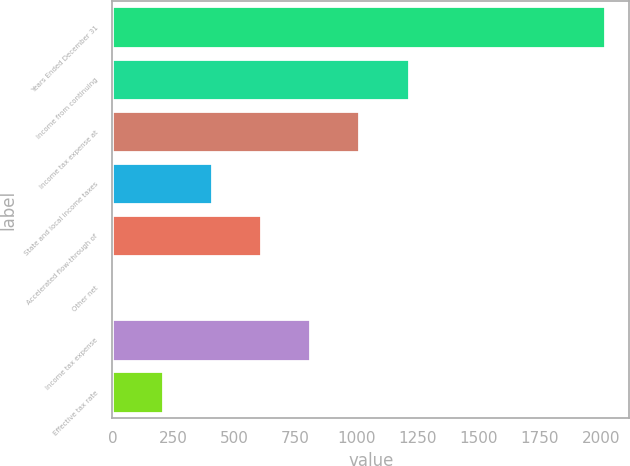Convert chart. <chart><loc_0><loc_0><loc_500><loc_500><bar_chart><fcel>Years Ended December 31<fcel>Income from continuing<fcel>Income tax expense at<fcel>State and local income taxes<fcel>Accelerated flow-through of<fcel>Other net<fcel>Income tax expense<fcel>Effective tax rate<nl><fcel>2016<fcel>1212.4<fcel>1011.5<fcel>408.8<fcel>609.7<fcel>7<fcel>810.6<fcel>207.9<nl></chart> 